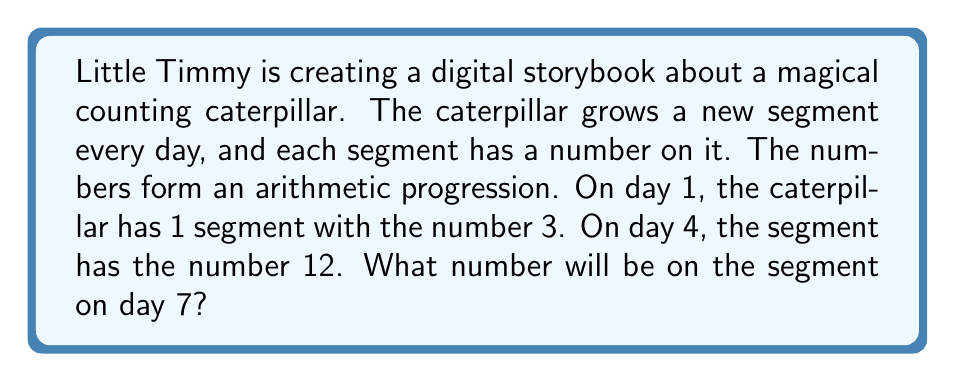Solve this math problem. Let's solve this step-by-step:

1) In an arithmetic progression, the difference between each term is constant. Let's call this common difference $d$.

2) We know two terms of the sequence:
   - 1st term (day 1): $a_1 = 3$
   - 4th term (day 4): $a_4 = 12$

3) The general formula for the nth term of an arithmetic sequence is:
   $a_n = a_1 + (n-1)d$

4) We can use this to find $d$:
   $12 = 3 + (4-1)d$
   $12 = 3 + 3d$
   $9 = 3d$
   $d = 3$

5) Now that we know $d$, we can find the 7th term:
   $a_7 = a_1 + (7-1)d$
   $a_7 = 3 + (6)(3)$
   $a_7 = 3 + 18$
   $a_7 = 21$

Therefore, on day 7, the segment will have the number 21.
Answer: 21 